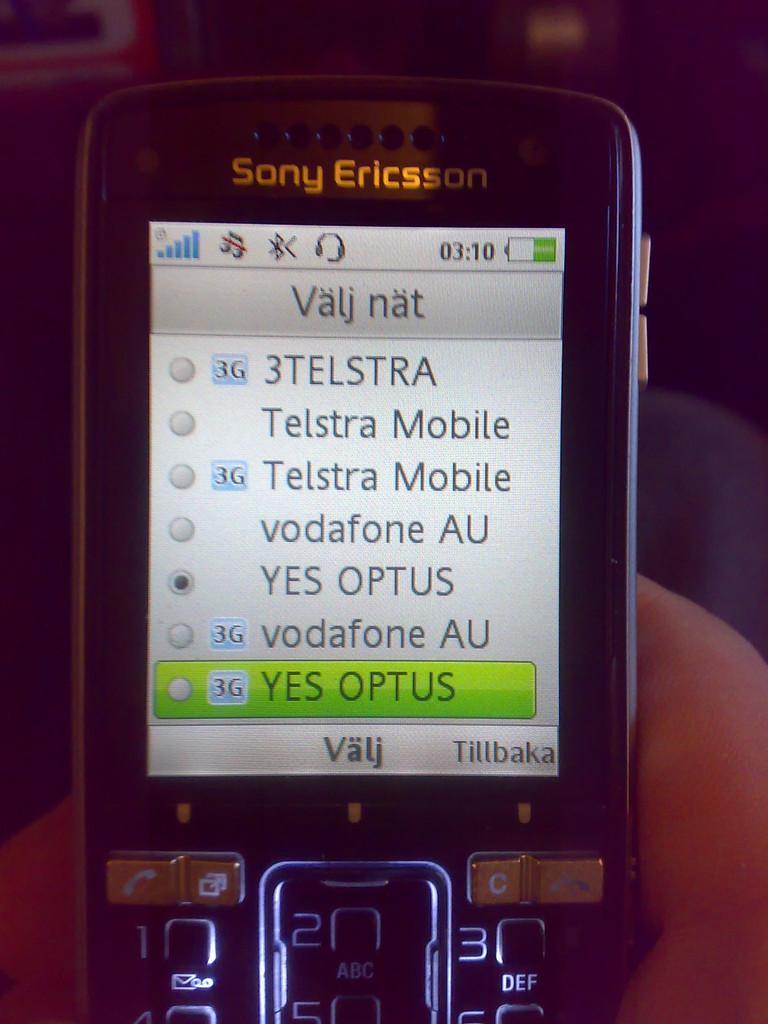<image>
Share a concise interpretation of the image provided. A Sony Ericsson phone which has the word Tillbaka on the bottom right. 